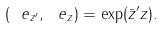<formula> <loc_0><loc_0><loc_500><loc_500>( \ e _ { z ^ { \prime } } , \ e _ { z } ) = \exp ( \bar { z } ^ { \prime } z ) .</formula> 